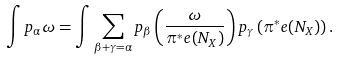<formula> <loc_0><loc_0><loc_500><loc_500>\int p _ { \alpha } \omega = \int \sum _ { \beta + \gamma = \alpha } p _ { \beta } \left ( \frac { \omega } { \pi ^ { * } e ( N _ { X } ) } \right ) p _ { \gamma } \left ( \pi ^ { * } e ( N _ { X } ) \right ) .</formula> 